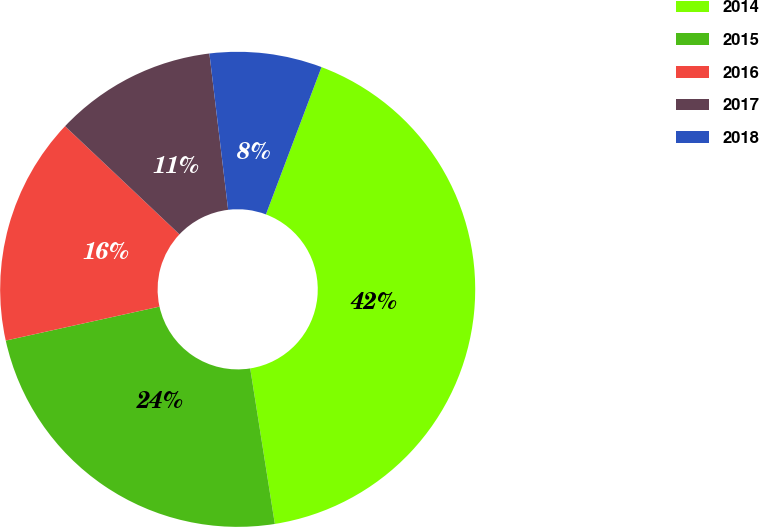Convert chart. <chart><loc_0><loc_0><loc_500><loc_500><pie_chart><fcel>2014<fcel>2015<fcel>2016<fcel>2017<fcel>2018<nl><fcel>41.76%<fcel>24.04%<fcel>15.51%<fcel>11.05%<fcel>7.64%<nl></chart> 